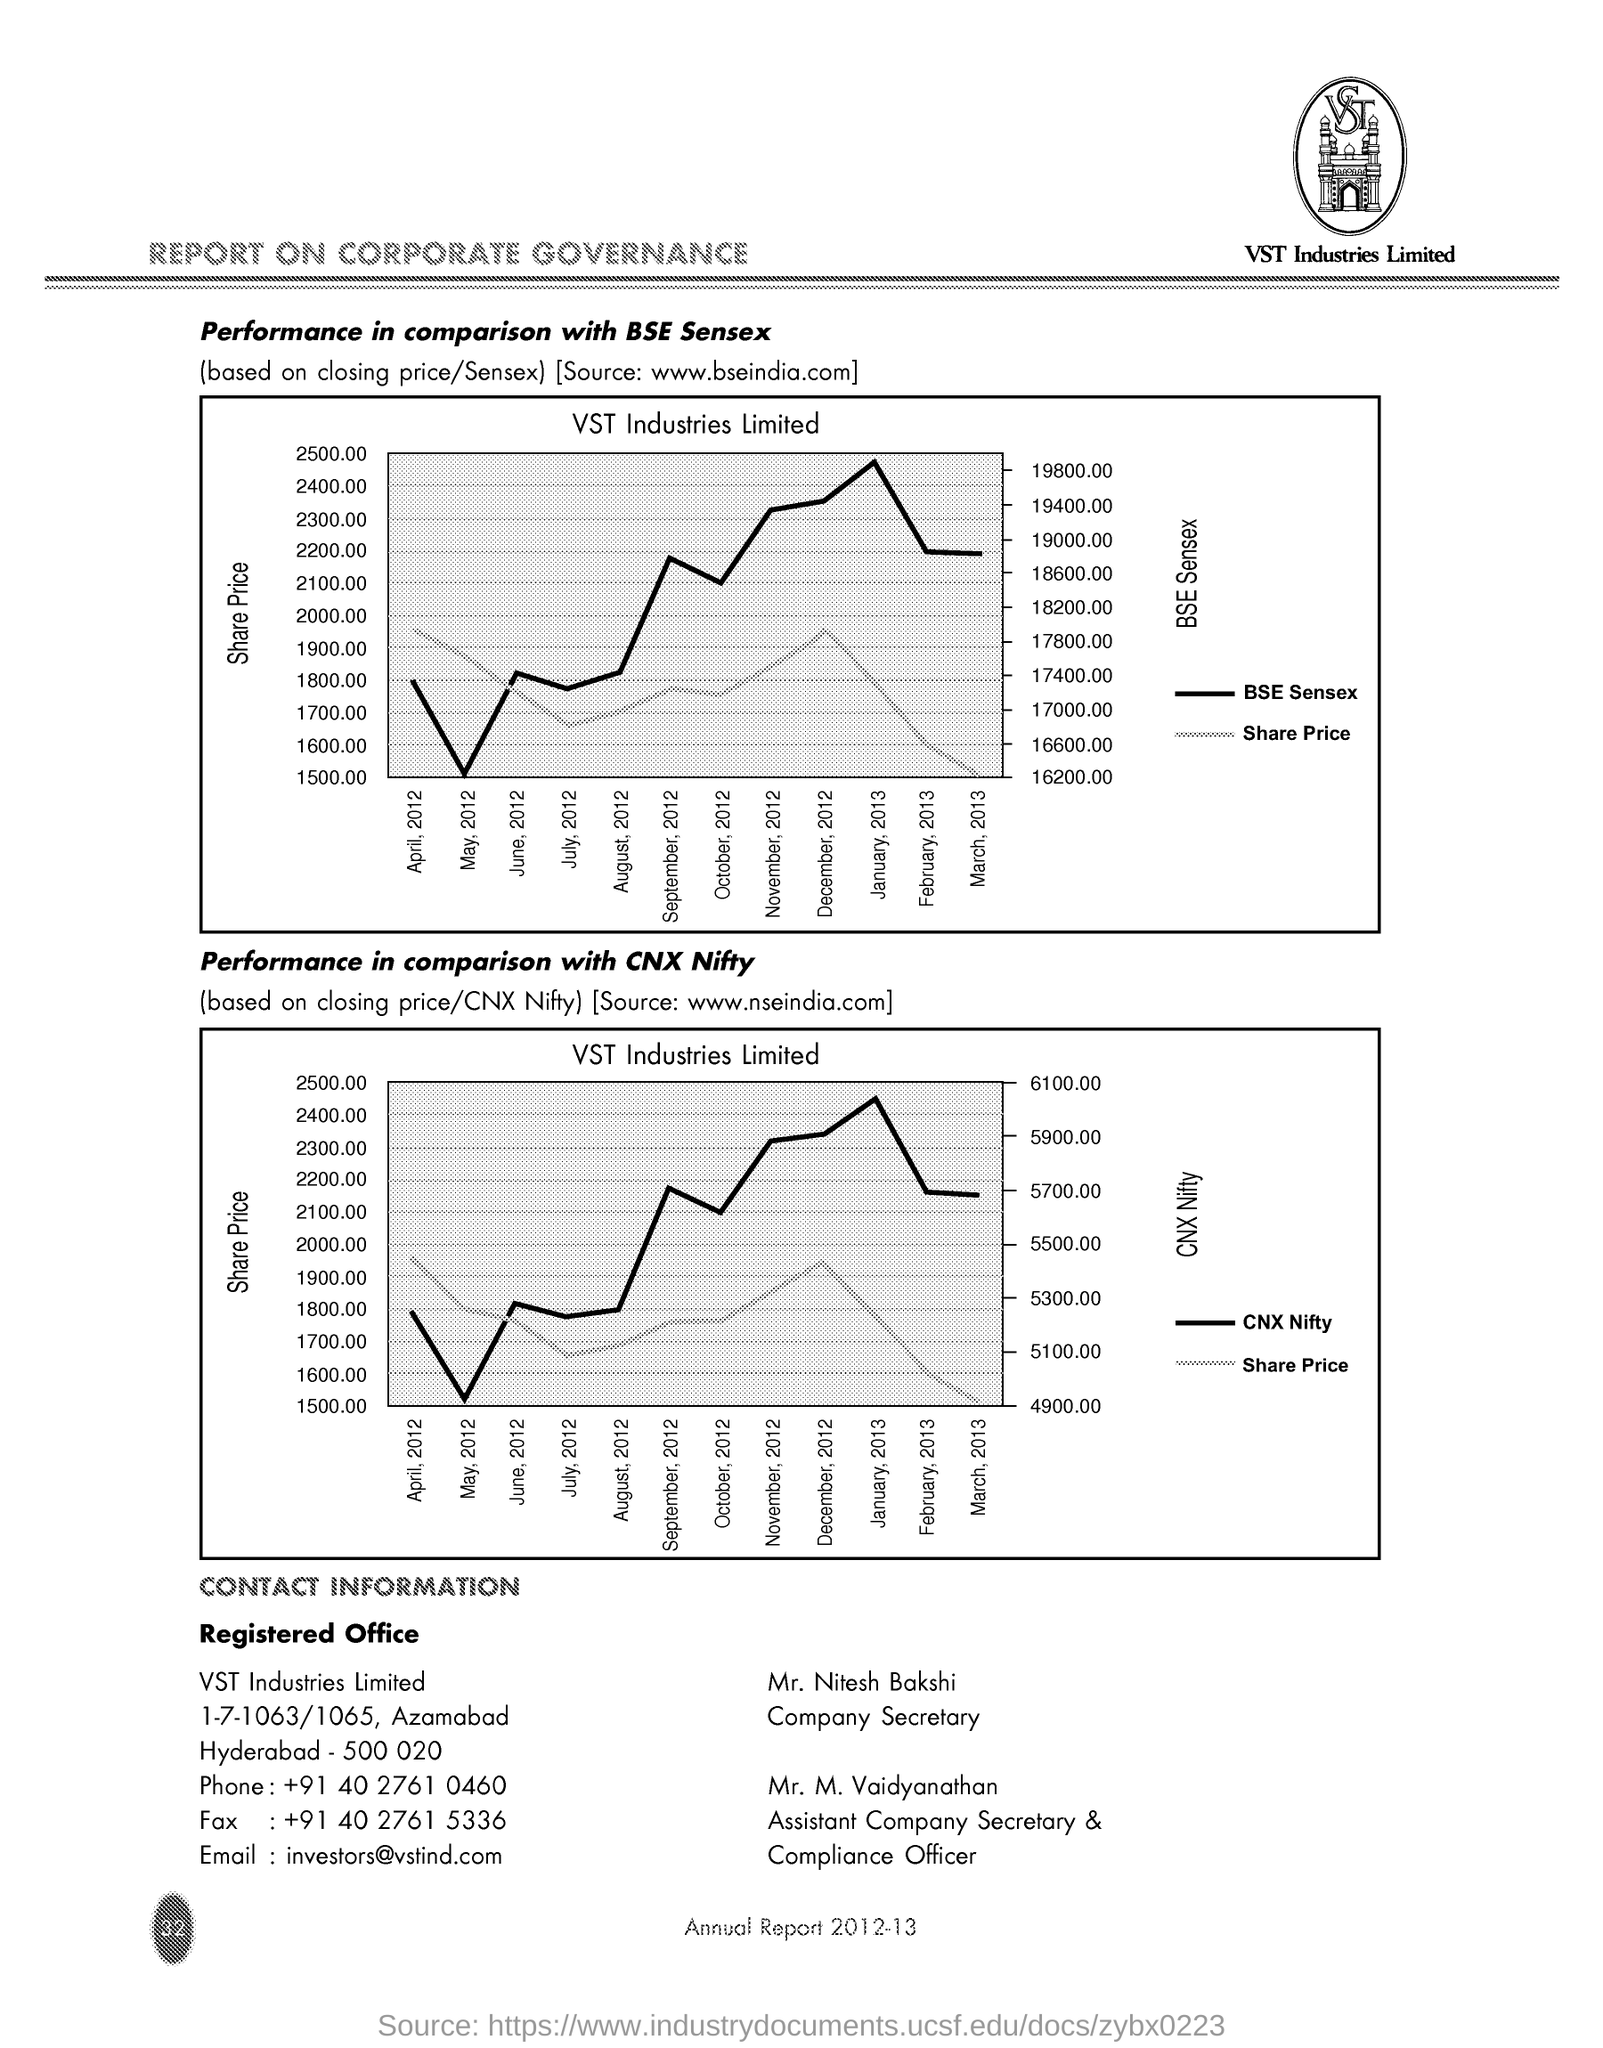What is the Industry Name ?
Give a very brief answer. VST. What is the Fax Number ?
Give a very brief answer. +91 40 2761 5336. Who is the Company Secretary ?
Provide a succinct answer. Mr. Nitesh Bakshi. Who is the Assistant Company Secretory & Compliance Officer ?
Give a very brief answer. Mr. M. Vaidyanathan. What is the Phone Number ?
Provide a succinct answer. +91 40 2761 0460. What is the Email Address ?
Your answer should be very brief. Investors@vstindcom. 